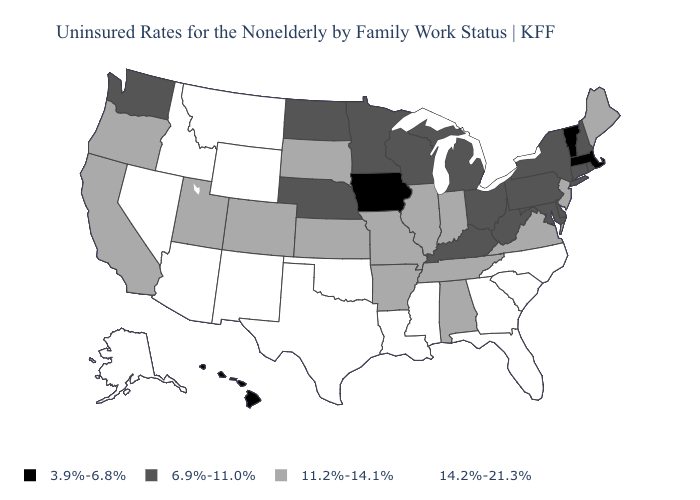Name the states that have a value in the range 11.2%-14.1%?
Short answer required. Alabama, Arkansas, California, Colorado, Illinois, Indiana, Kansas, Maine, Missouri, New Jersey, Oregon, South Dakota, Tennessee, Utah, Virginia. What is the value of Nevada?
Answer briefly. 14.2%-21.3%. Among the states that border Utah , does Arizona have the lowest value?
Write a very short answer. No. What is the value of Iowa?
Quick response, please. 3.9%-6.8%. Is the legend a continuous bar?
Give a very brief answer. No. How many symbols are there in the legend?
Quick response, please. 4. What is the highest value in states that border Delaware?
Keep it brief. 11.2%-14.1%. Which states have the highest value in the USA?
Answer briefly. Alaska, Arizona, Florida, Georgia, Idaho, Louisiana, Mississippi, Montana, Nevada, New Mexico, North Carolina, Oklahoma, South Carolina, Texas, Wyoming. Which states hav the highest value in the South?
Give a very brief answer. Florida, Georgia, Louisiana, Mississippi, North Carolina, Oklahoma, South Carolina, Texas. Is the legend a continuous bar?
Be succinct. No. Does Nebraska have the highest value in the USA?
Keep it brief. No. Name the states that have a value in the range 3.9%-6.8%?
Give a very brief answer. Hawaii, Iowa, Massachusetts, Vermont. Does the first symbol in the legend represent the smallest category?
Be succinct. Yes. Does Ohio have a lower value than Tennessee?
Answer briefly. Yes. 